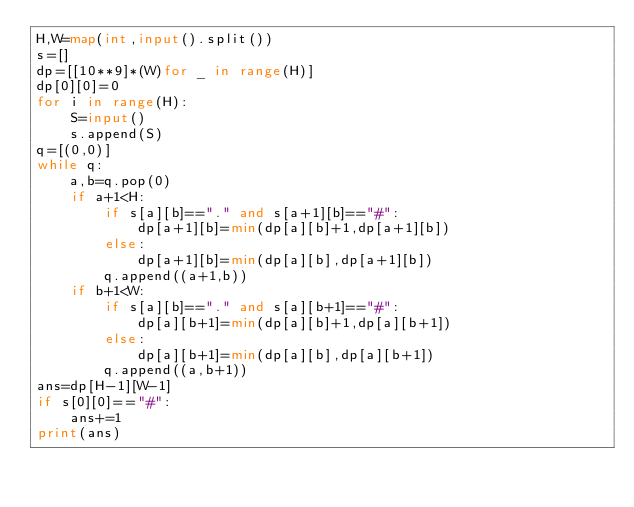<code> <loc_0><loc_0><loc_500><loc_500><_Python_>H,W=map(int,input().split())
s=[]
dp=[[10**9]*(W)for _ in range(H)]
dp[0][0]=0
for i in range(H):
    S=input()
    s.append(S)
q=[(0,0)]
while q:
    a,b=q.pop(0)
    if a+1<H:
        if s[a][b]=="." and s[a+1][b]=="#":
            dp[a+1][b]=min(dp[a][b]+1,dp[a+1][b])
        else:
            dp[a+1][b]=min(dp[a][b],dp[a+1][b])
        q.append((a+1,b))
    if b+1<W:
        if s[a][b]=="." and s[a][b+1]=="#":
            dp[a][b+1]=min(dp[a][b]+1,dp[a][b+1])
        else:
            dp[a][b+1]=min(dp[a][b],dp[a][b+1])
        q.append((a,b+1))
ans=dp[H-1][W-1]
if s[0][0]=="#":
    ans+=1
print(ans)</code> 